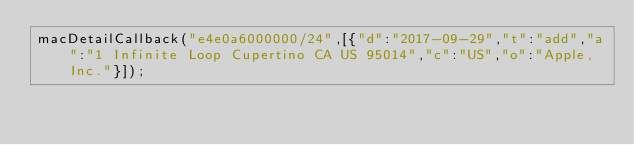<code> <loc_0><loc_0><loc_500><loc_500><_JavaScript_>macDetailCallback("e4e0a6000000/24",[{"d":"2017-09-29","t":"add","a":"1 Infinite Loop Cupertino CA US 95014","c":"US","o":"Apple, Inc."}]);
</code> 